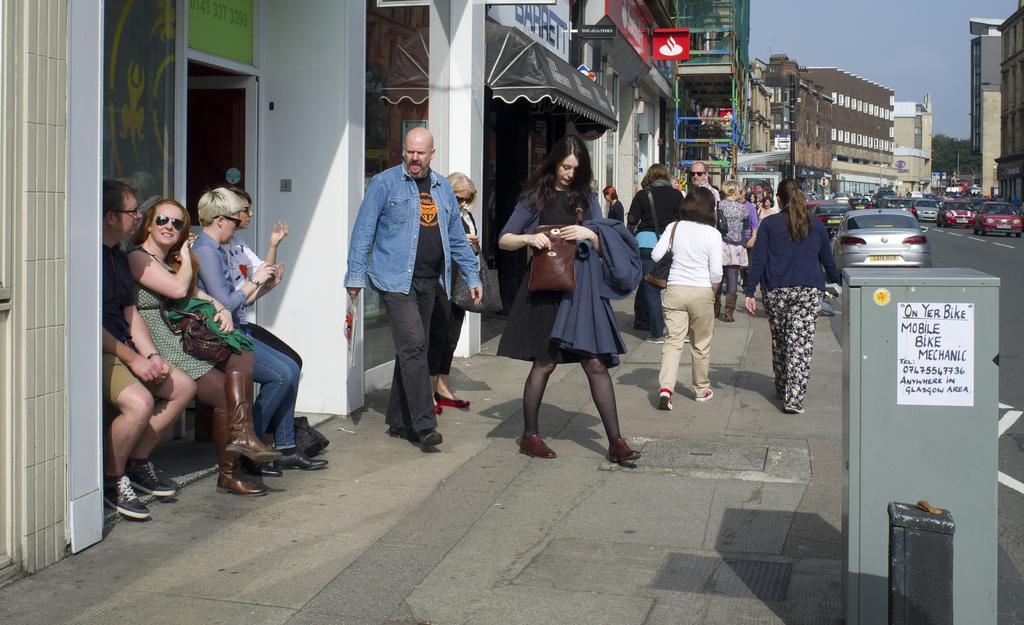Could you give a brief overview of what you see in this image? In this image in the front there are objects which are black and grey in colour and there is a poster on the object which is grey in colour with some text written on it. In the center there are persons sitting and walking. In the background there are buildings, cars, boards with some text written on it and there are persons, there are trees and at the top we can see sky. 